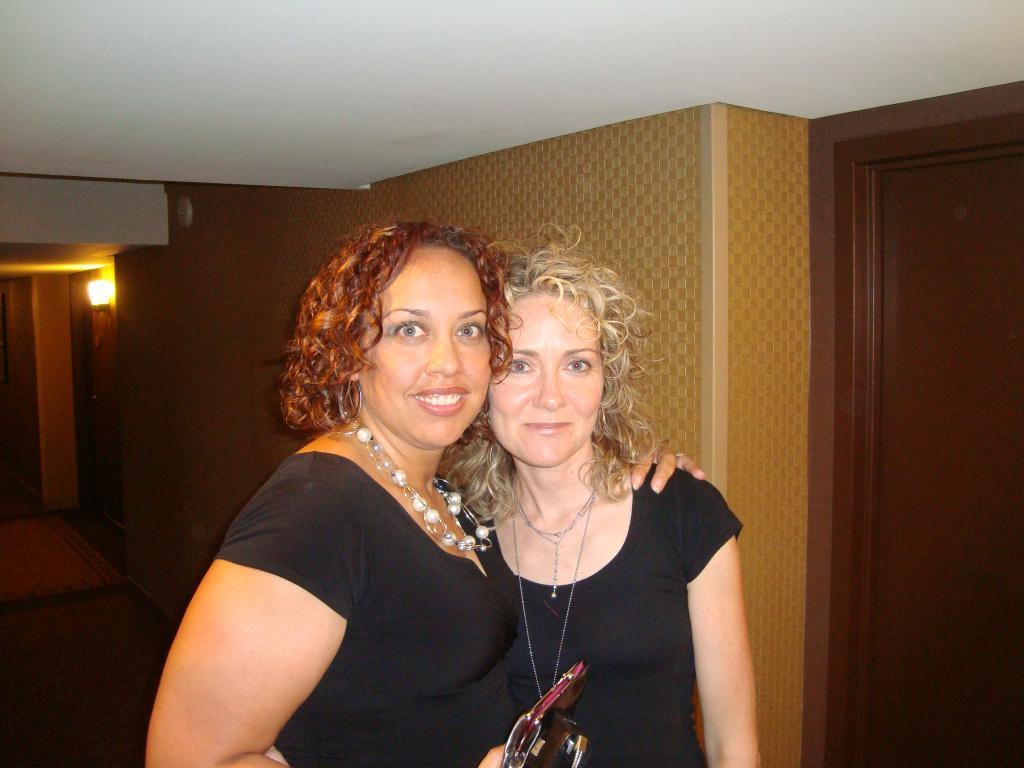Please provide a concise description of this image. The picture is taken in a room. In the foreground of the picture there are two woman standing, they are wearing black t-shirt. On the right there is a door. On the left there is a light and the floor. At the top it is ceiling painted white. 